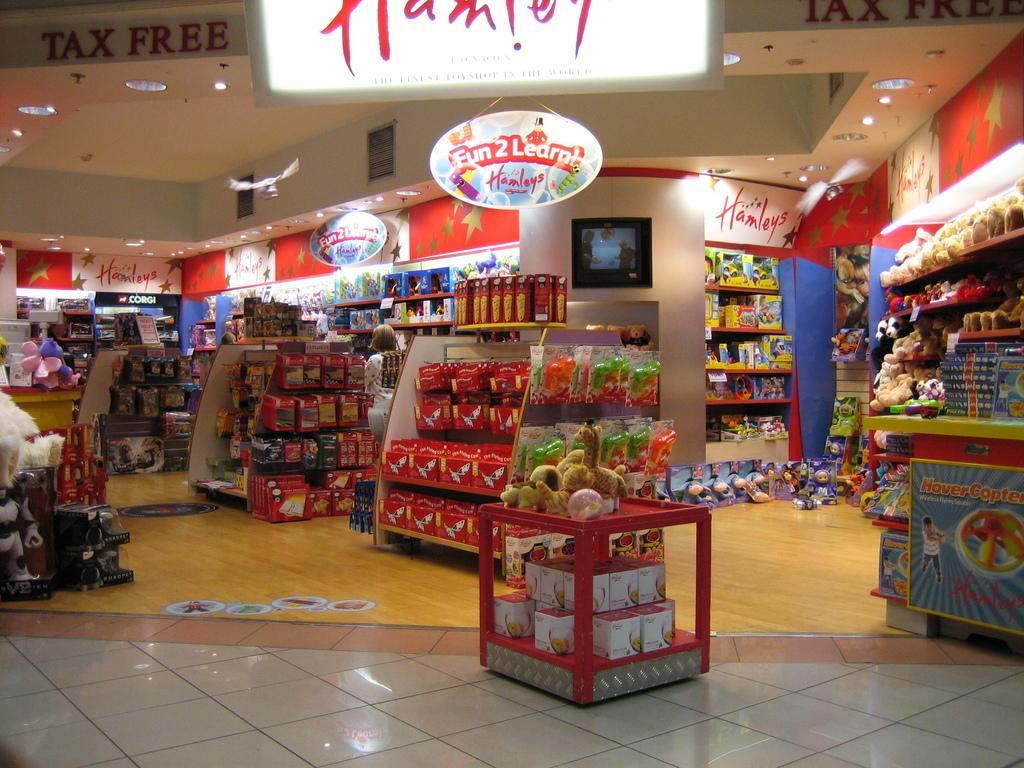<image>
Describe the image concisely. A sign is hanging from the ceiling of Hanley's stating Fun 2 Learn! 